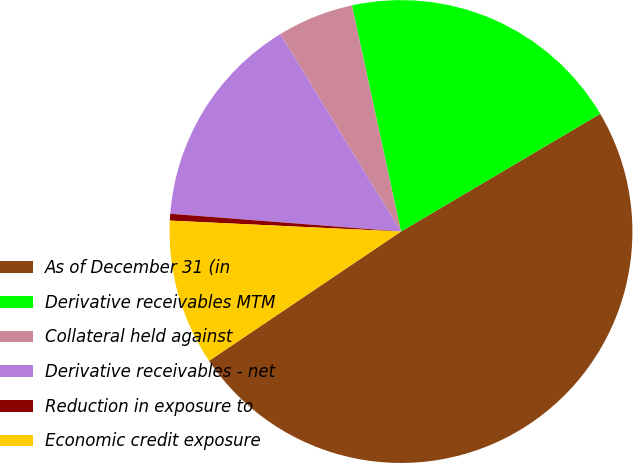Convert chart. <chart><loc_0><loc_0><loc_500><loc_500><pie_chart><fcel>As of December 31 (in<fcel>Derivative receivables MTM<fcel>Collateral held against<fcel>Derivative receivables - net<fcel>Reduction in exposure to<fcel>Economic credit exposure<nl><fcel>49.07%<fcel>19.91%<fcel>5.33%<fcel>15.05%<fcel>0.47%<fcel>10.19%<nl></chart> 